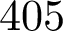<formula> <loc_0><loc_0><loc_500><loc_500>4 0 5</formula> 